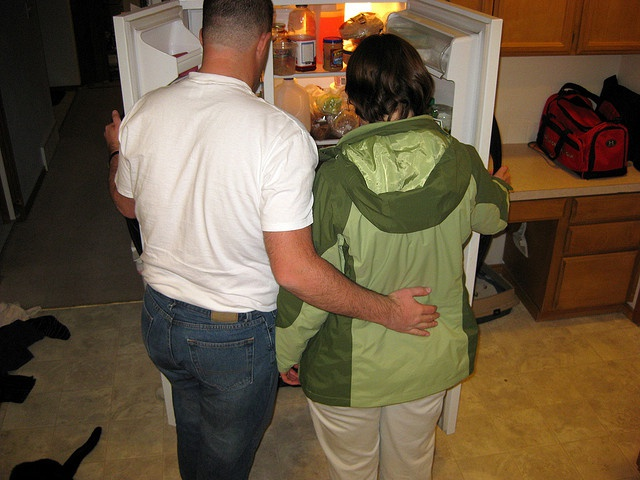Describe the objects in this image and their specific colors. I can see people in black, lightgray, and brown tones, people in black, olive, and darkgreen tones, refrigerator in black, darkgray, and gray tones, cat in black tones, and bottle in black, brown, red, and gray tones in this image. 